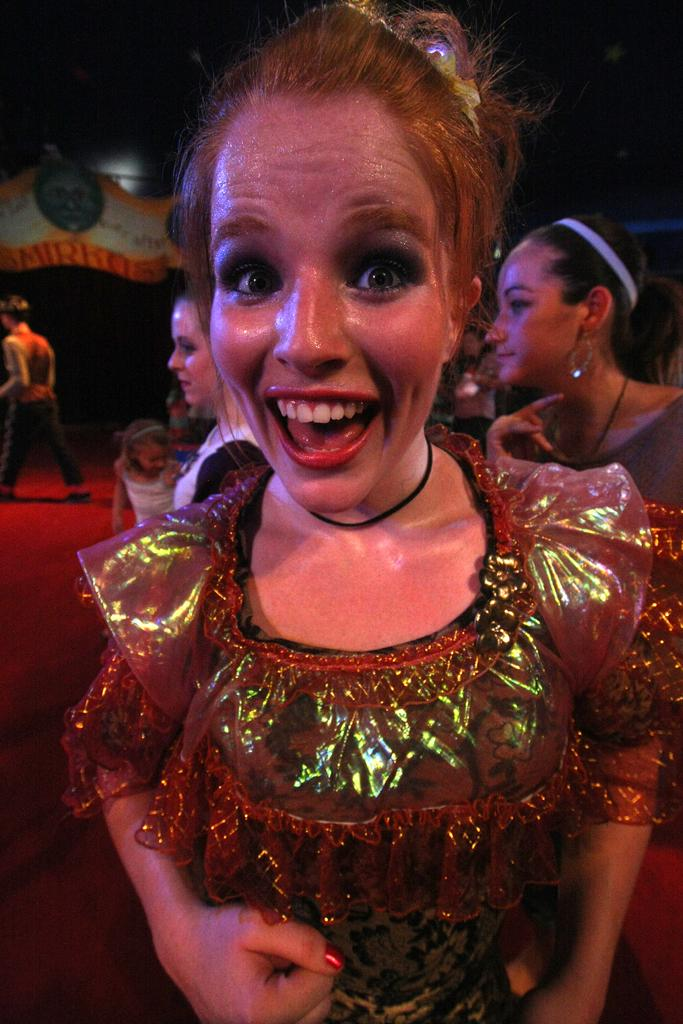Who is the main subject in the image? There is a woman in the image. What is the woman wearing? The woman is wearing a dress. What expression does the woman have? The woman is smiling. What can be seen in the background of the image? There are people walking and the floor is visible in the background of the image. Where are the fairies sitting in the image? There are no fairies present in the image. What type of worm can be seen crawling on the woman's dress? There is no worm visible on the woman's dress in the image. 